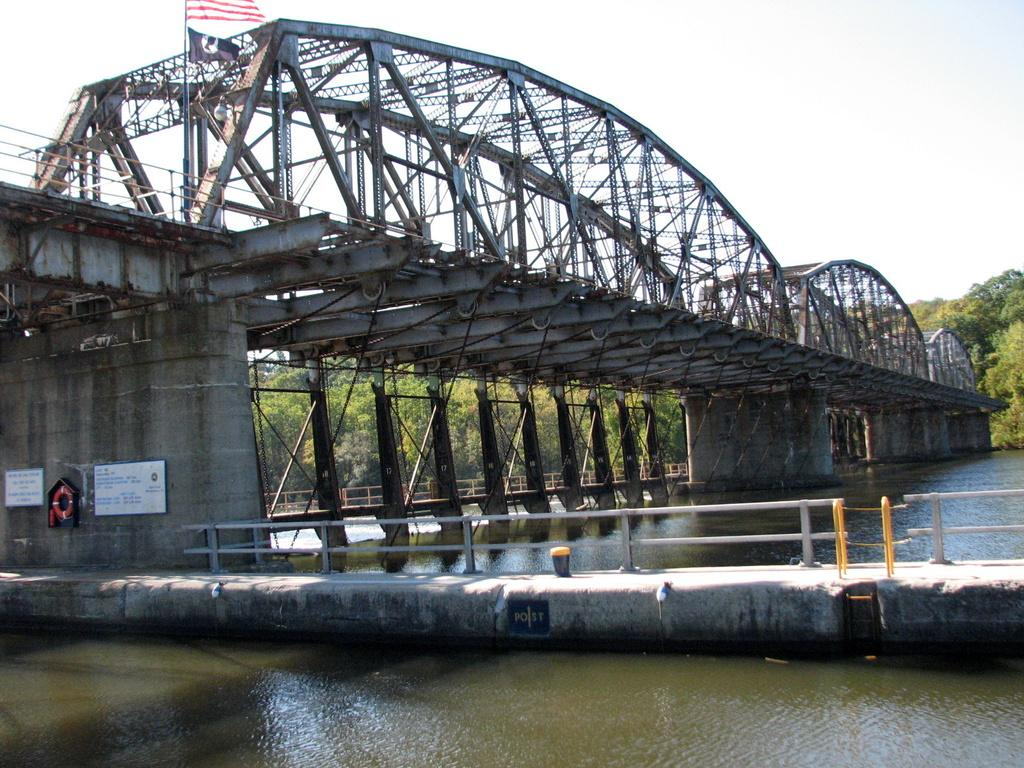What type of structure is present in the image? There is a metal bridge in the image. Where is the bridge located? The bridge is placed in water. What can be seen in the foreground of the image? There is a metal barricade in the foreground of the image. What is visible in the background of the image? There is a group of trees and the sky in the background of the image. What type of soup is being served in the image? There is no soup present in the image; it features a metal bridge placed in water. Can you tell me how many corks are visible in the image? There are no corks present in the image. 